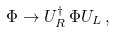<formula> <loc_0><loc_0><loc_500><loc_500>\Phi \rightarrow U _ { R } ^ { \dag } \, \Phi U _ { L } \, ,</formula> 